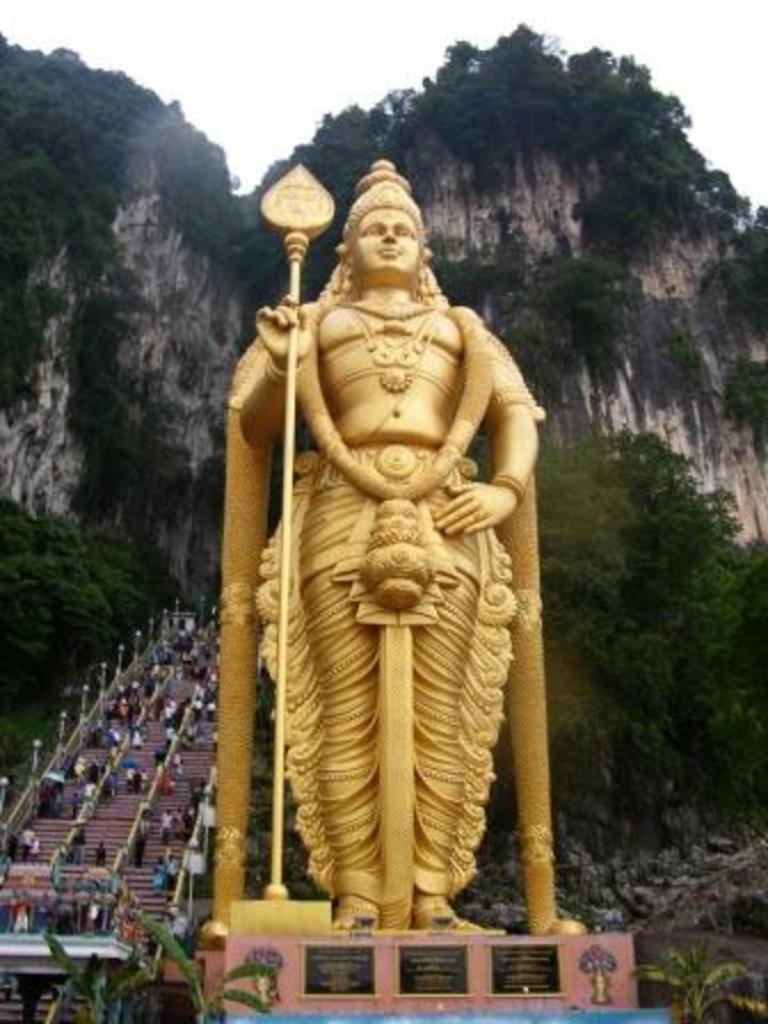In one or two sentences, can you explain what this image depicts? In this image, we can see a statue on an object. We can also see some boards with text. There are a few people. We can also see some stairs and the railing. There are a few trees and poles. We can also see some hills and the sky. 